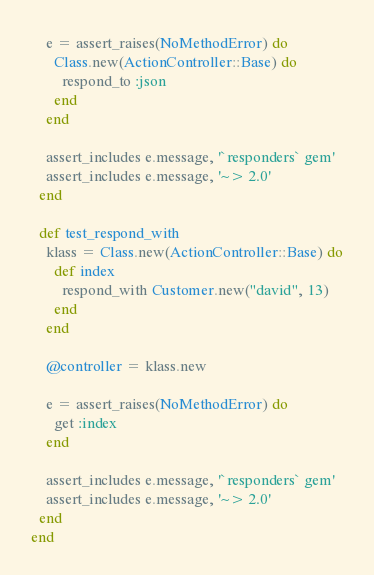<code> <loc_0><loc_0><loc_500><loc_500><_Ruby_>    e = assert_raises(NoMethodError) do
      Class.new(ActionController::Base) do
        respond_to :json
      end
    end

    assert_includes e.message, '`responders` gem'
    assert_includes e.message, '~> 2.0'
  end

  def test_respond_with
    klass = Class.new(ActionController::Base) do
      def index
        respond_with Customer.new("david", 13)
      end
    end

    @controller = klass.new

    e = assert_raises(NoMethodError) do
      get :index
    end

    assert_includes e.message, '`responders` gem'
    assert_includes e.message, '~> 2.0'
  end
end
</code> 